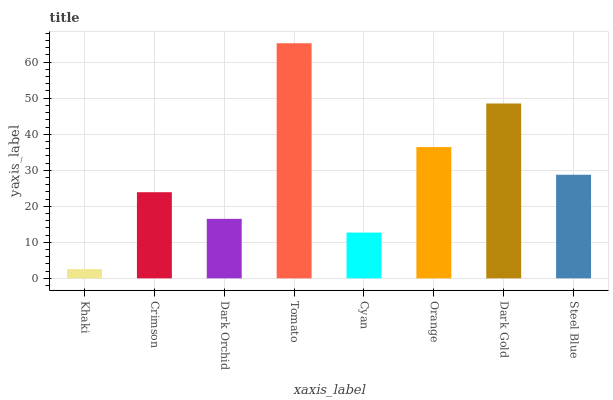Is Khaki the minimum?
Answer yes or no. Yes. Is Tomato the maximum?
Answer yes or no. Yes. Is Crimson the minimum?
Answer yes or no. No. Is Crimson the maximum?
Answer yes or no. No. Is Crimson greater than Khaki?
Answer yes or no. Yes. Is Khaki less than Crimson?
Answer yes or no. Yes. Is Khaki greater than Crimson?
Answer yes or no. No. Is Crimson less than Khaki?
Answer yes or no. No. Is Steel Blue the high median?
Answer yes or no. Yes. Is Crimson the low median?
Answer yes or no. Yes. Is Cyan the high median?
Answer yes or no. No. Is Khaki the low median?
Answer yes or no. No. 